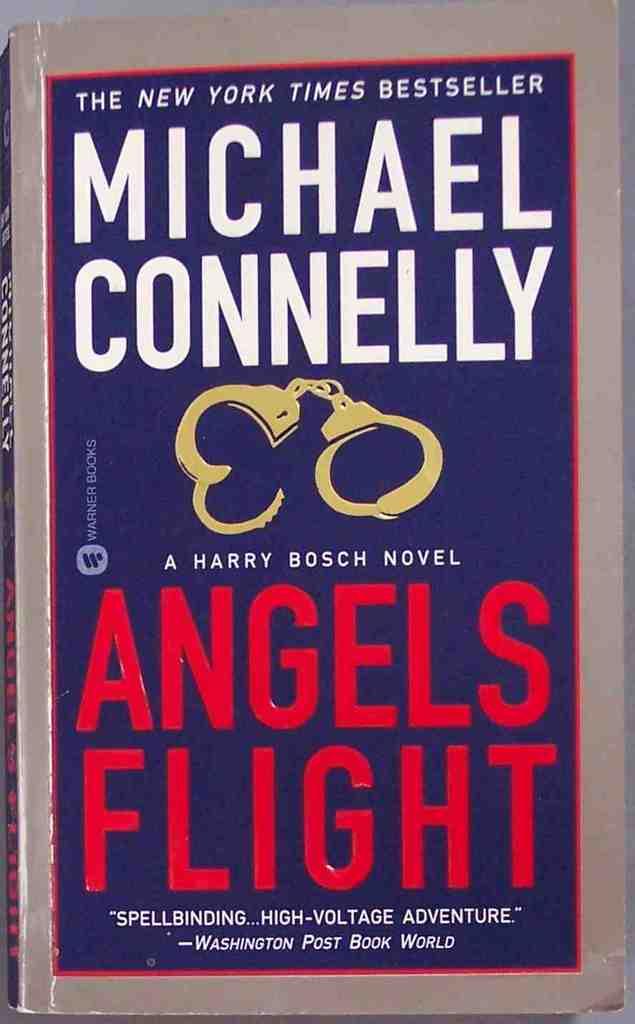What is the title of the book?
Give a very brief answer. Angels flight. What organization's review is shown on the bottom of the cover?
Your answer should be very brief. Washington post. 